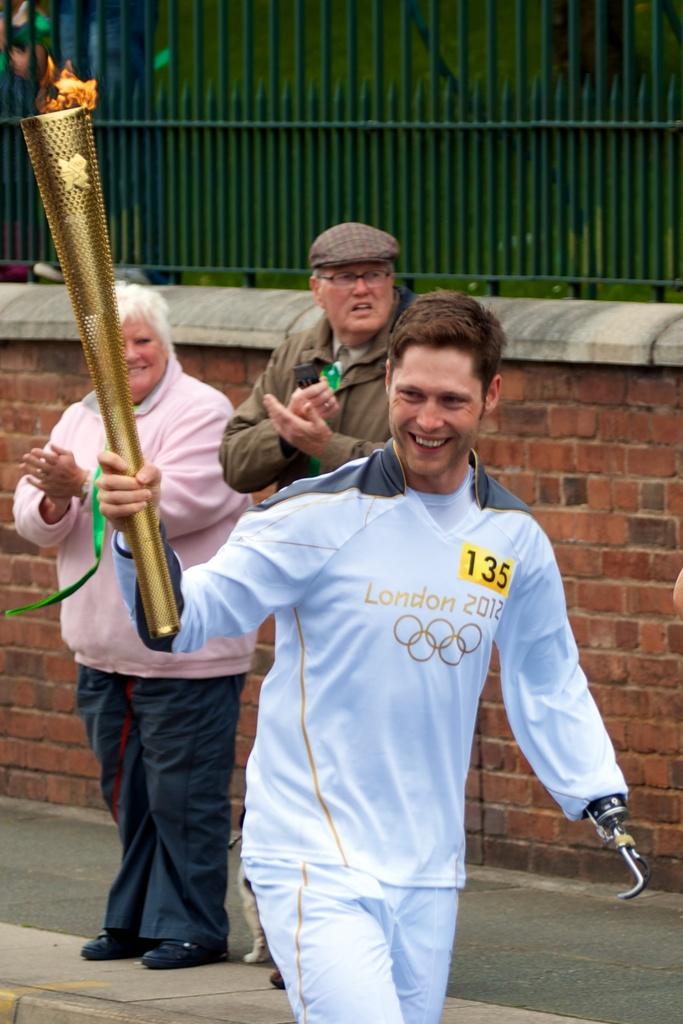What city was this event held in?
Make the answer very short. London. What number is this person?
Your answer should be very brief. 135. 